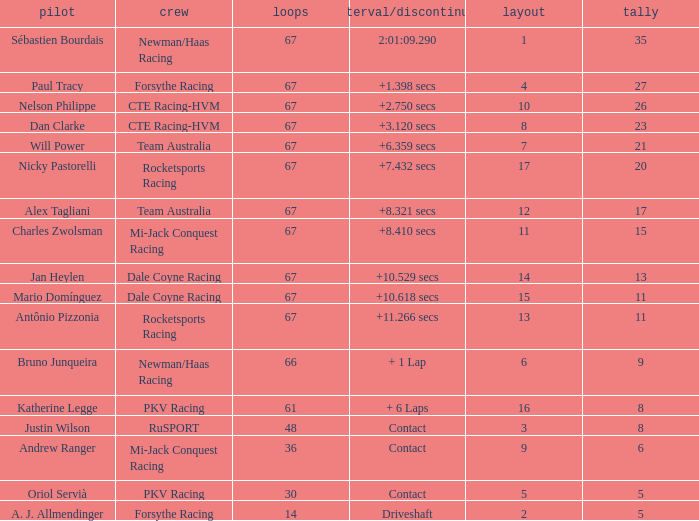How many average laps for Alex Tagliani with more than 17 points? None. 